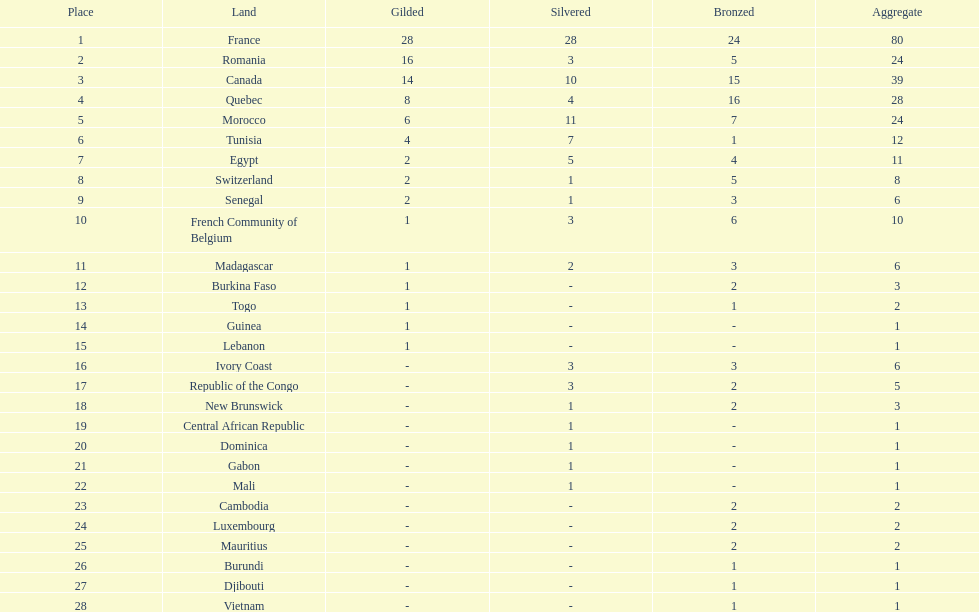How many more medals did egypt win than ivory coast? 5. 